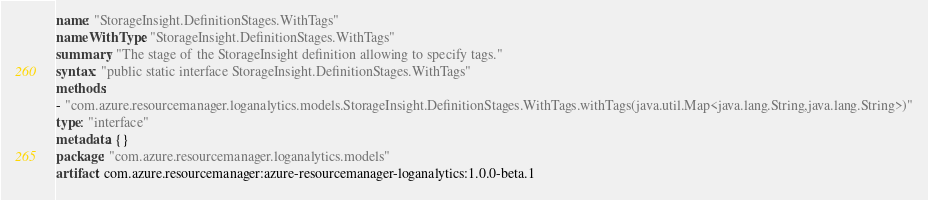<code> <loc_0><loc_0><loc_500><loc_500><_YAML_>name: "StorageInsight.DefinitionStages.WithTags"
nameWithType: "StorageInsight.DefinitionStages.WithTags"
summary: "The stage of the StorageInsight definition allowing to specify tags."
syntax: "public static interface StorageInsight.DefinitionStages.WithTags"
methods:
- "com.azure.resourcemanager.loganalytics.models.StorageInsight.DefinitionStages.WithTags.withTags(java.util.Map<java.lang.String,java.lang.String>)"
type: "interface"
metadata: {}
package: "com.azure.resourcemanager.loganalytics.models"
artifact: com.azure.resourcemanager:azure-resourcemanager-loganalytics:1.0.0-beta.1
</code> 